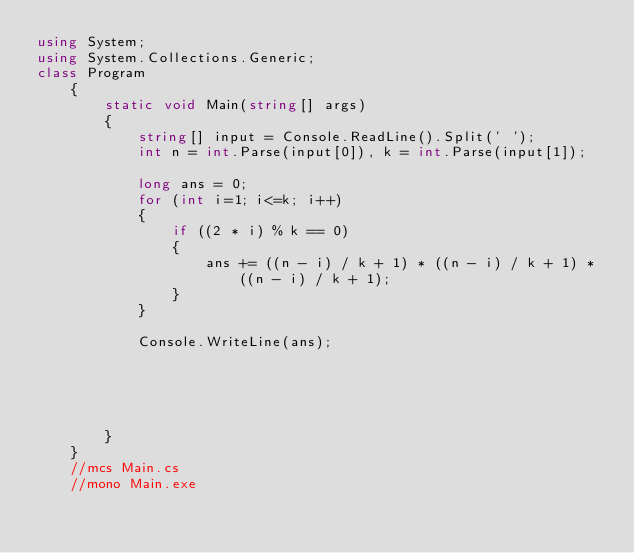Convert code to text. <code><loc_0><loc_0><loc_500><loc_500><_C#_>using System;
using System.Collections.Generic;
class Program
    {
        static void Main(string[] args)
        {
            string[] input = Console.ReadLine().Split(' ');
            int n = int.Parse(input[0]), k = int.Parse(input[1]);
            
            long ans = 0;
            for (int i=1; i<=k; i++)
            {
                if ((2 * i) % k == 0)
                {
                    ans += ((n - i) / k + 1) * ((n - i) / k + 1) * ((n - i) / k + 1);
                } 
            }

            Console.WriteLine(ans);
            
            


            
        }
    }
    //mcs Main.cs
    //mono Main.exe</code> 